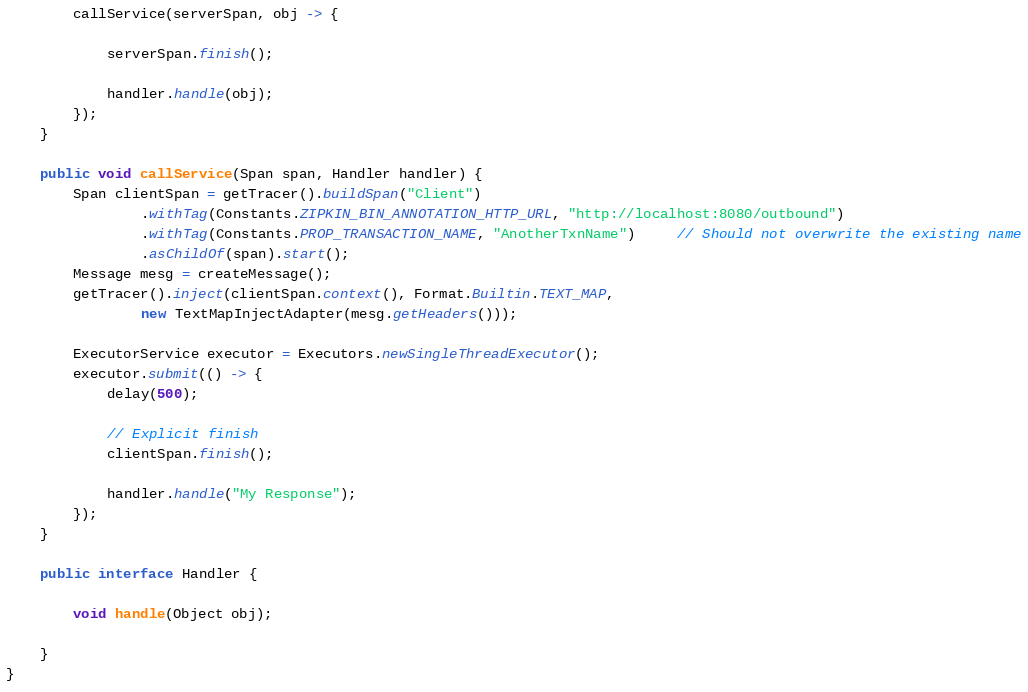<code> <loc_0><loc_0><loc_500><loc_500><_Java_>
        callService(serverSpan, obj -> {

            serverSpan.finish();

            handler.handle(obj);
        });
    }

    public void callService(Span span, Handler handler) {
        Span clientSpan = getTracer().buildSpan("Client")
                .withTag(Constants.ZIPKIN_BIN_ANNOTATION_HTTP_URL, "http://localhost:8080/outbound")
                .withTag(Constants.PROP_TRANSACTION_NAME, "AnotherTxnName")     // Should not overwrite the existing name
                .asChildOf(span).start();
        Message mesg = createMessage();
        getTracer().inject(clientSpan.context(), Format.Builtin.TEXT_MAP,
                new TextMapInjectAdapter(mesg.getHeaders()));

        ExecutorService executor = Executors.newSingleThreadExecutor();
        executor.submit(() -> {
            delay(500);

            // Explicit finish
            clientSpan.finish();

            handler.handle("My Response");
        });
    }

    public interface Handler {

        void handle(Object obj);

    }
}
</code> 